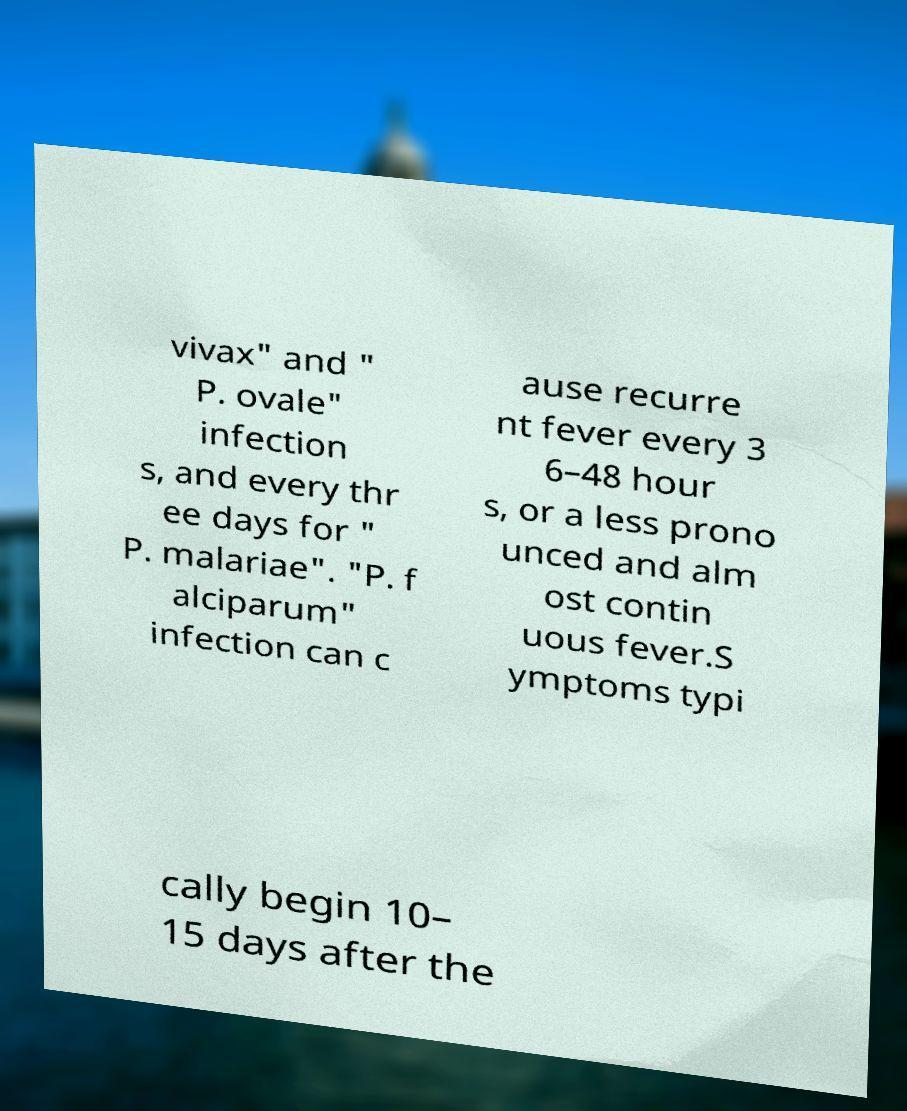For documentation purposes, I need the text within this image transcribed. Could you provide that? vivax" and " P. ovale" infection s, and every thr ee days for " P. malariae". "P. f alciparum" infection can c ause recurre nt fever every 3 6–48 hour s, or a less prono unced and alm ost contin uous fever.S ymptoms typi cally begin 10– 15 days after the 